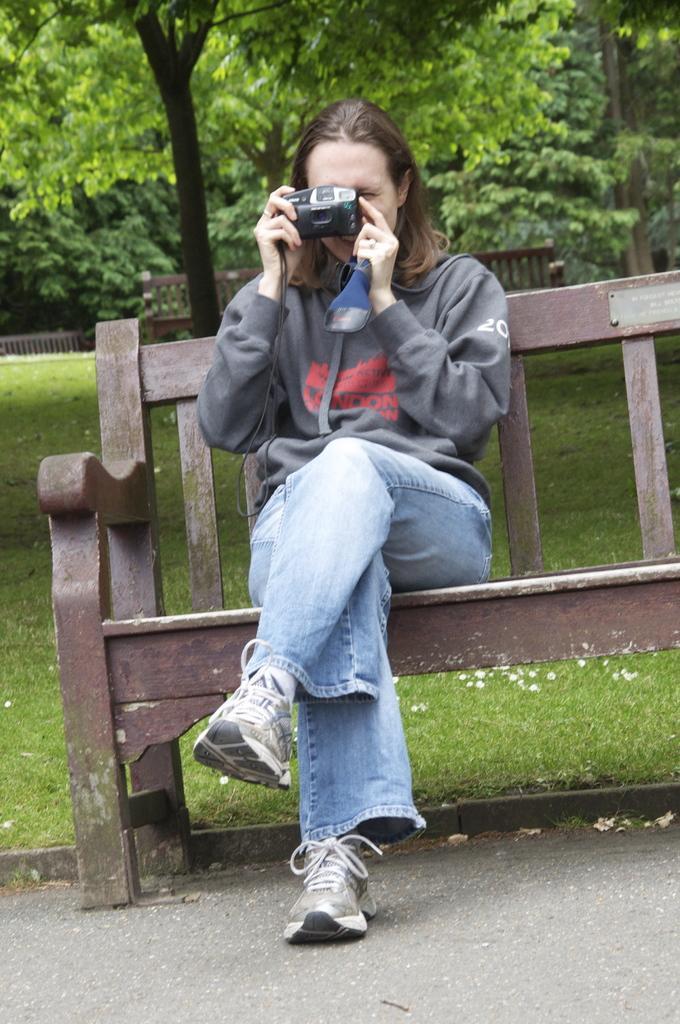Describe this image in one or two sentences. In this image I can see a woman is sitting on a bench. I can also see she is wearing a hoodie and holding a camera. In the background I can see few more benches and few trees. 